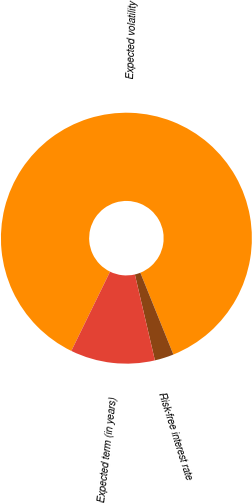<chart> <loc_0><loc_0><loc_500><loc_500><pie_chart><fcel>Expected volatility<fcel>Risk-free interest rate<fcel>Expected term (in years)<nl><fcel>86.67%<fcel>2.46%<fcel>10.88%<nl></chart> 